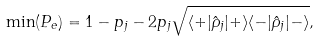<formula> <loc_0><loc_0><loc_500><loc_500>\min ( P _ { e } ) = 1 - p _ { j } - 2 p _ { j } \sqrt { \langle + | \hat { \rho } _ { j } | + \rangle \langle - | \hat { \rho } _ { j } | - \rangle } ,</formula> 